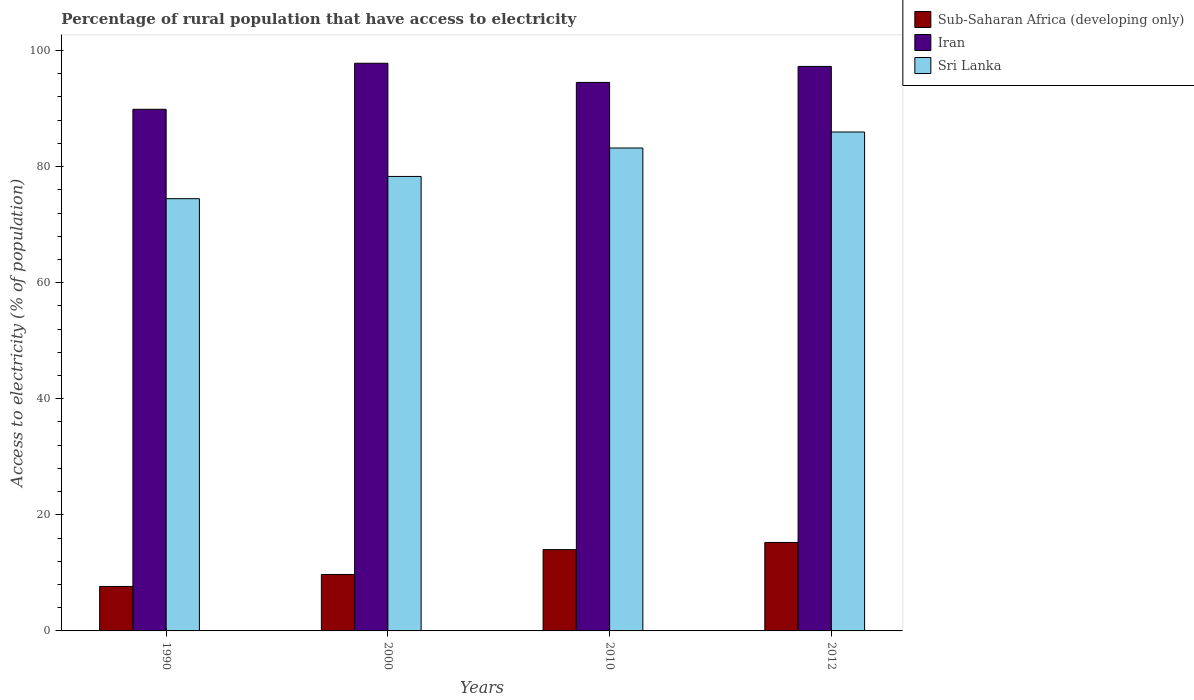How many different coloured bars are there?
Keep it short and to the point. 3. Are the number of bars on each tick of the X-axis equal?
Your answer should be compact. Yes. How many bars are there on the 1st tick from the right?
Your answer should be very brief. 3. What is the percentage of rural population that have access to electricity in Sri Lanka in 1990?
Offer a terse response. 74.47. Across all years, what is the maximum percentage of rural population that have access to electricity in Iran?
Offer a terse response. 97.8. Across all years, what is the minimum percentage of rural population that have access to electricity in Iran?
Keep it short and to the point. 89.87. In which year was the percentage of rural population that have access to electricity in Sub-Saharan Africa (developing only) minimum?
Provide a short and direct response. 1990. What is the total percentage of rural population that have access to electricity in Sri Lanka in the graph?
Keep it short and to the point. 321.92. What is the difference between the percentage of rural population that have access to electricity in Iran in 2010 and that in 2012?
Provide a succinct answer. -2.75. What is the difference between the percentage of rural population that have access to electricity in Sri Lanka in 2000 and the percentage of rural population that have access to electricity in Iran in 1990?
Offer a terse response. -11.57. What is the average percentage of rural population that have access to electricity in Sri Lanka per year?
Offer a terse response. 80.48. In the year 2010, what is the difference between the percentage of rural population that have access to electricity in Sub-Saharan Africa (developing only) and percentage of rural population that have access to electricity in Iran?
Give a very brief answer. -80.49. In how many years, is the percentage of rural population that have access to electricity in Sub-Saharan Africa (developing only) greater than 88 %?
Your answer should be very brief. 0. What is the ratio of the percentage of rural population that have access to electricity in Sub-Saharan Africa (developing only) in 1990 to that in 2000?
Keep it short and to the point. 0.79. What is the difference between the highest and the second highest percentage of rural population that have access to electricity in Sri Lanka?
Your answer should be compact. 2.75. What is the difference between the highest and the lowest percentage of rural population that have access to electricity in Iran?
Keep it short and to the point. 7.93. Is the sum of the percentage of rural population that have access to electricity in Sri Lanka in 2010 and 2012 greater than the maximum percentage of rural population that have access to electricity in Iran across all years?
Provide a succinct answer. Yes. What does the 1st bar from the left in 2012 represents?
Your response must be concise. Sub-Saharan Africa (developing only). What does the 3rd bar from the right in 2000 represents?
Ensure brevity in your answer.  Sub-Saharan Africa (developing only). Are all the bars in the graph horizontal?
Keep it short and to the point. No. What is the difference between two consecutive major ticks on the Y-axis?
Your response must be concise. 20. Does the graph contain grids?
Keep it short and to the point. No. What is the title of the graph?
Make the answer very short. Percentage of rural population that have access to electricity. Does "Ecuador" appear as one of the legend labels in the graph?
Provide a succinct answer. No. What is the label or title of the Y-axis?
Offer a very short reply. Access to electricity (% of population). What is the Access to electricity (% of population) of Sub-Saharan Africa (developing only) in 1990?
Your answer should be very brief. 7.66. What is the Access to electricity (% of population) of Iran in 1990?
Your answer should be compact. 89.87. What is the Access to electricity (% of population) in Sri Lanka in 1990?
Keep it short and to the point. 74.47. What is the Access to electricity (% of population) of Sub-Saharan Africa (developing only) in 2000?
Your answer should be compact. 9.73. What is the Access to electricity (% of population) in Iran in 2000?
Provide a succinct answer. 97.8. What is the Access to electricity (% of population) in Sri Lanka in 2000?
Keep it short and to the point. 78.3. What is the Access to electricity (% of population) in Sub-Saharan Africa (developing only) in 2010?
Keep it short and to the point. 14.01. What is the Access to electricity (% of population) of Iran in 2010?
Provide a short and direct response. 94.5. What is the Access to electricity (% of population) in Sri Lanka in 2010?
Offer a terse response. 83.2. What is the Access to electricity (% of population) of Sub-Saharan Africa (developing only) in 2012?
Give a very brief answer. 15.24. What is the Access to electricity (% of population) in Iran in 2012?
Offer a very short reply. 97.25. What is the Access to electricity (% of population) in Sri Lanka in 2012?
Offer a terse response. 85.95. Across all years, what is the maximum Access to electricity (% of population) in Sub-Saharan Africa (developing only)?
Your response must be concise. 15.24. Across all years, what is the maximum Access to electricity (% of population) of Iran?
Offer a terse response. 97.8. Across all years, what is the maximum Access to electricity (% of population) of Sri Lanka?
Offer a terse response. 85.95. Across all years, what is the minimum Access to electricity (% of population) in Sub-Saharan Africa (developing only)?
Provide a succinct answer. 7.66. Across all years, what is the minimum Access to electricity (% of population) of Iran?
Your answer should be compact. 89.87. Across all years, what is the minimum Access to electricity (% of population) in Sri Lanka?
Provide a short and direct response. 74.47. What is the total Access to electricity (% of population) in Sub-Saharan Africa (developing only) in the graph?
Offer a very short reply. 46.64. What is the total Access to electricity (% of population) in Iran in the graph?
Ensure brevity in your answer.  379.42. What is the total Access to electricity (% of population) of Sri Lanka in the graph?
Offer a terse response. 321.92. What is the difference between the Access to electricity (% of population) of Sub-Saharan Africa (developing only) in 1990 and that in 2000?
Provide a short and direct response. -2.06. What is the difference between the Access to electricity (% of population) in Iran in 1990 and that in 2000?
Offer a very short reply. -7.93. What is the difference between the Access to electricity (% of population) of Sri Lanka in 1990 and that in 2000?
Provide a short and direct response. -3.83. What is the difference between the Access to electricity (% of population) of Sub-Saharan Africa (developing only) in 1990 and that in 2010?
Provide a short and direct response. -6.34. What is the difference between the Access to electricity (% of population) in Iran in 1990 and that in 2010?
Your response must be concise. -4.63. What is the difference between the Access to electricity (% of population) in Sri Lanka in 1990 and that in 2010?
Your answer should be compact. -8.73. What is the difference between the Access to electricity (% of population) of Sub-Saharan Africa (developing only) in 1990 and that in 2012?
Offer a very short reply. -7.58. What is the difference between the Access to electricity (% of population) in Iran in 1990 and that in 2012?
Give a very brief answer. -7.38. What is the difference between the Access to electricity (% of population) of Sri Lanka in 1990 and that in 2012?
Offer a terse response. -11.48. What is the difference between the Access to electricity (% of population) in Sub-Saharan Africa (developing only) in 2000 and that in 2010?
Ensure brevity in your answer.  -4.28. What is the difference between the Access to electricity (% of population) of Sub-Saharan Africa (developing only) in 2000 and that in 2012?
Your answer should be compact. -5.52. What is the difference between the Access to electricity (% of population) in Iran in 2000 and that in 2012?
Keep it short and to the point. 0.55. What is the difference between the Access to electricity (% of population) in Sri Lanka in 2000 and that in 2012?
Provide a short and direct response. -7.65. What is the difference between the Access to electricity (% of population) in Sub-Saharan Africa (developing only) in 2010 and that in 2012?
Make the answer very short. -1.24. What is the difference between the Access to electricity (% of population) in Iran in 2010 and that in 2012?
Provide a succinct answer. -2.75. What is the difference between the Access to electricity (% of population) in Sri Lanka in 2010 and that in 2012?
Make the answer very short. -2.75. What is the difference between the Access to electricity (% of population) in Sub-Saharan Africa (developing only) in 1990 and the Access to electricity (% of population) in Iran in 2000?
Offer a terse response. -90.14. What is the difference between the Access to electricity (% of population) in Sub-Saharan Africa (developing only) in 1990 and the Access to electricity (% of population) in Sri Lanka in 2000?
Provide a short and direct response. -70.64. What is the difference between the Access to electricity (% of population) in Iran in 1990 and the Access to electricity (% of population) in Sri Lanka in 2000?
Make the answer very short. 11.57. What is the difference between the Access to electricity (% of population) of Sub-Saharan Africa (developing only) in 1990 and the Access to electricity (% of population) of Iran in 2010?
Your answer should be compact. -86.84. What is the difference between the Access to electricity (% of population) in Sub-Saharan Africa (developing only) in 1990 and the Access to electricity (% of population) in Sri Lanka in 2010?
Make the answer very short. -75.54. What is the difference between the Access to electricity (% of population) of Iran in 1990 and the Access to electricity (% of population) of Sri Lanka in 2010?
Provide a succinct answer. 6.67. What is the difference between the Access to electricity (% of population) of Sub-Saharan Africa (developing only) in 1990 and the Access to electricity (% of population) of Iran in 2012?
Offer a very short reply. -89.59. What is the difference between the Access to electricity (% of population) in Sub-Saharan Africa (developing only) in 1990 and the Access to electricity (% of population) in Sri Lanka in 2012?
Ensure brevity in your answer.  -78.29. What is the difference between the Access to electricity (% of population) of Iran in 1990 and the Access to electricity (% of population) of Sri Lanka in 2012?
Your answer should be compact. 3.92. What is the difference between the Access to electricity (% of population) in Sub-Saharan Africa (developing only) in 2000 and the Access to electricity (% of population) in Iran in 2010?
Offer a terse response. -84.77. What is the difference between the Access to electricity (% of population) in Sub-Saharan Africa (developing only) in 2000 and the Access to electricity (% of population) in Sri Lanka in 2010?
Your response must be concise. -73.47. What is the difference between the Access to electricity (% of population) in Iran in 2000 and the Access to electricity (% of population) in Sri Lanka in 2010?
Give a very brief answer. 14.6. What is the difference between the Access to electricity (% of population) in Sub-Saharan Africa (developing only) in 2000 and the Access to electricity (% of population) in Iran in 2012?
Your answer should be very brief. -87.53. What is the difference between the Access to electricity (% of population) of Sub-Saharan Africa (developing only) in 2000 and the Access to electricity (% of population) of Sri Lanka in 2012?
Provide a succinct answer. -76.23. What is the difference between the Access to electricity (% of population) in Iran in 2000 and the Access to electricity (% of population) in Sri Lanka in 2012?
Provide a succinct answer. 11.85. What is the difference between the Access to electricity (% of population) in Sub-Saharan Africa (developing only) in 2010 and the Access to electricity (% of population) in Iran in 2012?
Your answer should be compact. -83.25. What is the difference between the Access to electricity (% of population) of Sub-Saharan Africa (developing only) in 2010 and the Access to electricity (% of population) of Sri Lanka in 2012?
Provide a short and direct response. -71.95. What is the difference between the Access to electricity (% of population) of Iran in 2010 and the Access to electricity (% of population) of Sri Lanka in 2012?
Your response must be concise. 8.55. What is the average Access to electricity (% of population) of Sub-Saharan Africa (developing only) per year?
Make the answer very short. 11.66. What is the average Access to electricity (% of population) of Iran per year?
Offer a very short reply. 94.86. What is the average Access to electricity (% of population) in Sri Lanka per year?
Keep it short and to the point. 80.48. In the year 1990, what is the difference between the Access to electricity (% of population) in Sub-Saharan Africa (developing only) and Access to electricity (% of population) in Iran?
Offer a terse response. -82.21. In the year 1990, what is the difference between the Access to electricity (% of population) in Sub-Saharan Africa (developing only) and Access to electricity (% of population) in Sri Lanka?
Your answer should be compact. -66.81. In the year 2000, what is the difference between the Access to electricity (% of population) in Sub-Saharan Africa (developing only) and Access to electricity (% of population) in Iran?
Your answer should be compact. -88.07. In the year 2000, what is the difference between the Access to electricity (% of population) of Sub-Saharan Africa (developing only) and Access to electricity (% of population) of Sri Lanka?
Offer a very short reply. -68.57. In the year 2000, what is the difference between the Access to electricity (% of population) of Iran and Access to electricity (% of population) of Sri Lanka?
Give a very brief answer. 19.5. In the year 2010, what is the difference between the Access to electricity (% of population) in Sub-Saharan Africa (developing only) and Access to electricity (% of population) in Iran?
Ensure brevity in your answer.  -80.49. In the year 2010, what is the difference between the Access to electricity (% of population) of Sub-Saharan Africa (developing only) and Access to electricity (% of population) of Sri Lanka?
Your answer should be compact. -69.19. In the year 2010, what is the difference between the Access to electricity (% of population) in Iran and Access to electricity (% of population) in Sri Lanka?
Give a very brief answer. 11.3. In the year 2012, what is the difference between the Access to electricity (% of population) in Sub-Saharan Africa (developing only) and Access to electricity (% of population) in Iran?
Keep it short and to the point. -82.01. In the year 2012, what is the difference between the Access to electricity (% of population) in Sub-Saharan Africa (developing only) and Access to electricity (% of population) in Sri Lanka?
Keep it short and to the point. -70.71. In the year 2012, what is the difference between the Access to electricity (% of population) in Iran and Access to electricity (% of population) in Sri Lanka?
Make the answer very short. 11.3. What is the ratio of the Access to electricity (% of population) of Sub-Saharan Africa (developing only) in 1990 to that in 2000?
Keep it short and to the point. 0.79. What is the ratio of the Access to electricity (% of population) of Iran in 1990 to that in 2000?
Make the answer very short. 0.92. What is the ratio of the Access to electricity (% of population) in Sri Lanka in 1990 to that in 2000?
Provide a short and direct response. 0.95. What is the ratio of the Access to electricity (% of population) in Sub-Saharan Africa (developing only) in 1990 to that in 2010?
Your response must be concise. 0.55. What is the ratio of the Access to electricity (% of population) of Iran in 1990 to that in 2010?
Your answer should be compact. 0.95. What is the ratio of the Access to electricity (% of population) of Sri Lanka in 1990 to that in 2010?
Provide a short and direct response. 0.9. What is the ratio of the Access to electricity (% of population) in Sub-Saharan Africa (developing only) in 1990 to that in 2012?
Your answer should be very brief. 0.5. What is the ratio of the Access to electricity (% of population) in Iran in 1990 to that in 2012?
Provide a succinct answer. 0.92. What is the ratio of the Access to electricity (% of population) of Sri Lanka in 1990 to that in 2012?
Your response must be concise. 0.87. What is the ratio of the Access to electricity (% of population) of Sub-Saharan Africa (developing only) in 2000 to that in 2010?
Your response must be concise. 0.69. What is the ratio of the Access to electricity (% of population) of Iran in 2000 to that in 2010?
Offer a terse response. 1.03. What is the ratio of the Access to electricity (% of population) of Sri Lanka in 2000 to that in 2010?
Provide a succinct answer. 0.94. What is the ratio of the Access to electricity (% of population) of Sub-Saharan Africa (developing only) in 2000 to that in 2012?
Offer a very short reply. 0.64. What is the ratio of the Access to electricity (% of population) in Iran in 2000 to that in 2012?
Your answer should be compact. 1.01. What is the ratio of the Access to electricity (% of population) in Sri Lanka in 2000 to that in 2012?
Make the answer very short. 0.91. What is the ratio of the Access to electricity (% of population) of Sub-Saharan Africa (developing only) in 2010 to that in 2012?
Your answer should be compact. 0.92. What is the ratio of the Access to electricity (% of population) in Iran in 2010 to that in 2012?
Provide a short and direct response. 0.97. What is the difference between the highest and the second highest Access to electricity (% of population) in Sub-Saharan Africa (developing only)?
Keep it short and to the point. 1.24. What is the difference between the highest and the second highest Access to electricity (% of population) in Iran?
Ensure brevity in your answer.  0.55. What is the difference between the highest and the second highest Access to electricity (% of population) in Sri Lanka?
Offer a very short reply. 2.75. What is the difference between the highest and the lowest Access to electricity (% of population) in Sub-Saharan Africa (developing only)?
Keep it short and to the point. 7.58. What is the difference between the highest and the lowest Access to electricity (% of population) of Iran?
Your response must be concise. 7.93. What is the difference between the highest and the lowest Access to electricity (% of population) of Sri Lanka?
Make the answer very short. 11.48. 